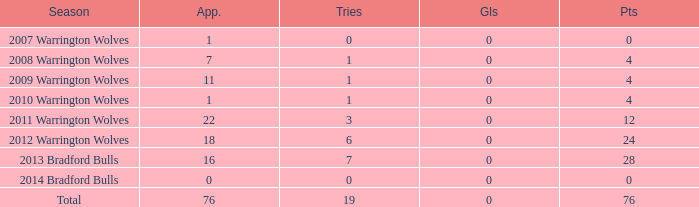What is the average tries for the season 2008 warrington wolves with an appearance more than 7? None. 